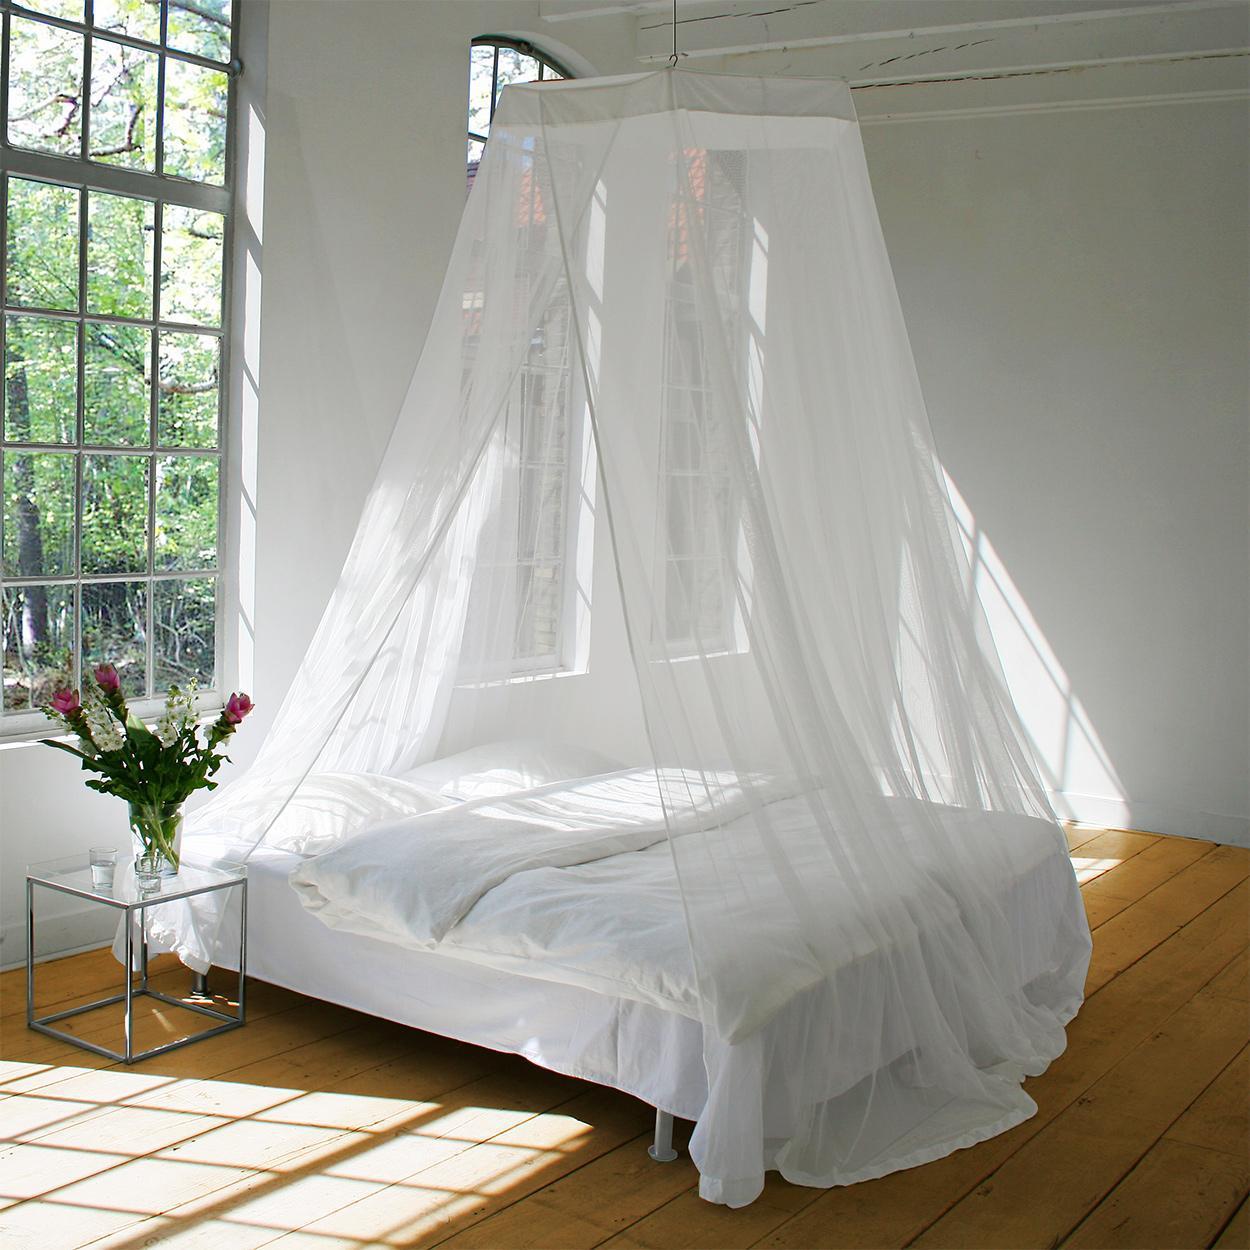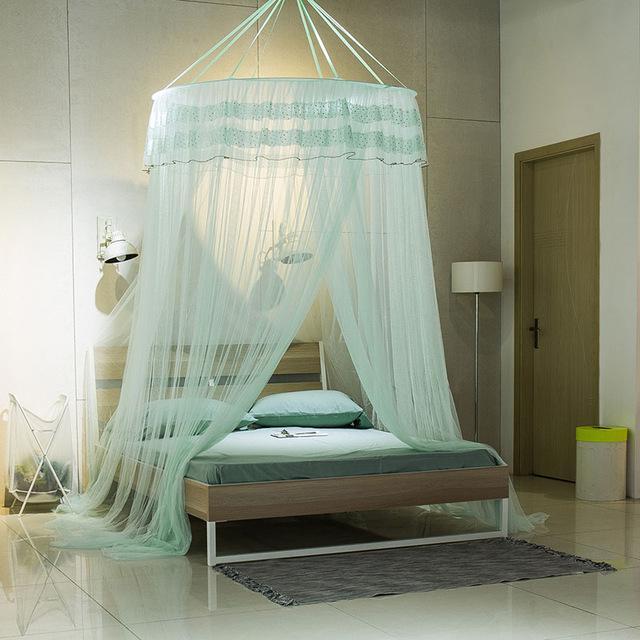The first image is the image on the left, the second image is the image on the right. For the images displayed, is the sentence "The left and right image contains the same number of canopies with at least one green one." factually correct? Answer yes or no. Yes. The first image is the image on the left, the second image is the image on the right. Given the left and right images, does the statement "Each image shows a gauzy canopy that drapes from a round shape suspended from the ceiling, and the right image features an aqua canopy with a ruffle around the top." hold true? Answer yes or no. Yes. 